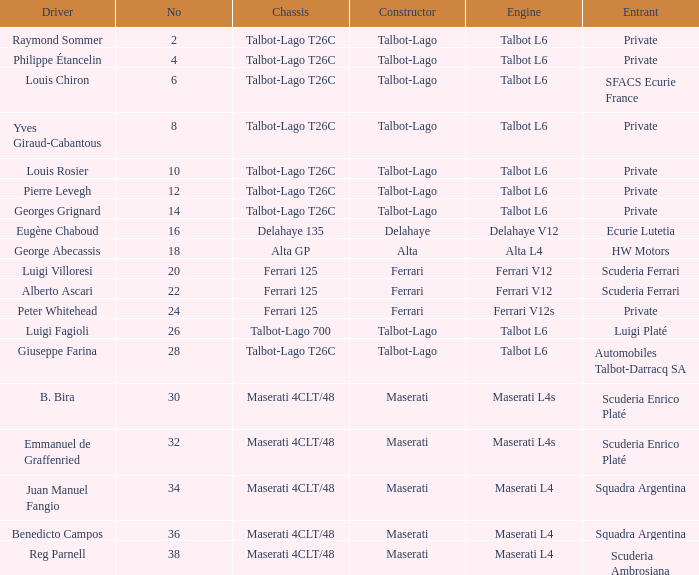Name the constructor for b. bira Maserati. 